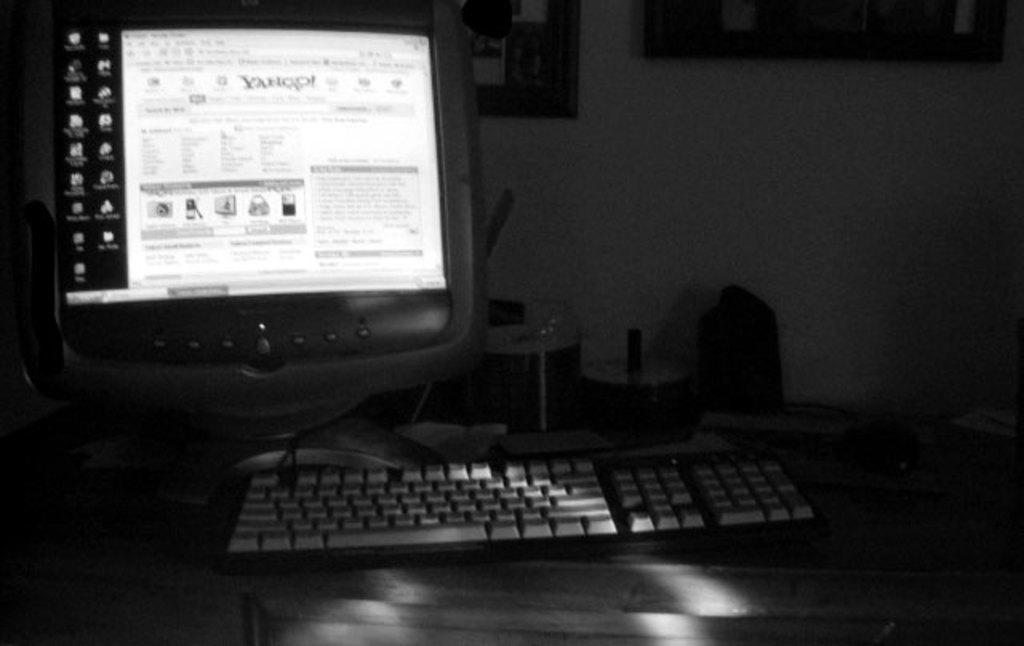<image>
Give a short and clear explanation of the subsequent image. A computer screen and keboard. The screen shows a Yahoo web page. 